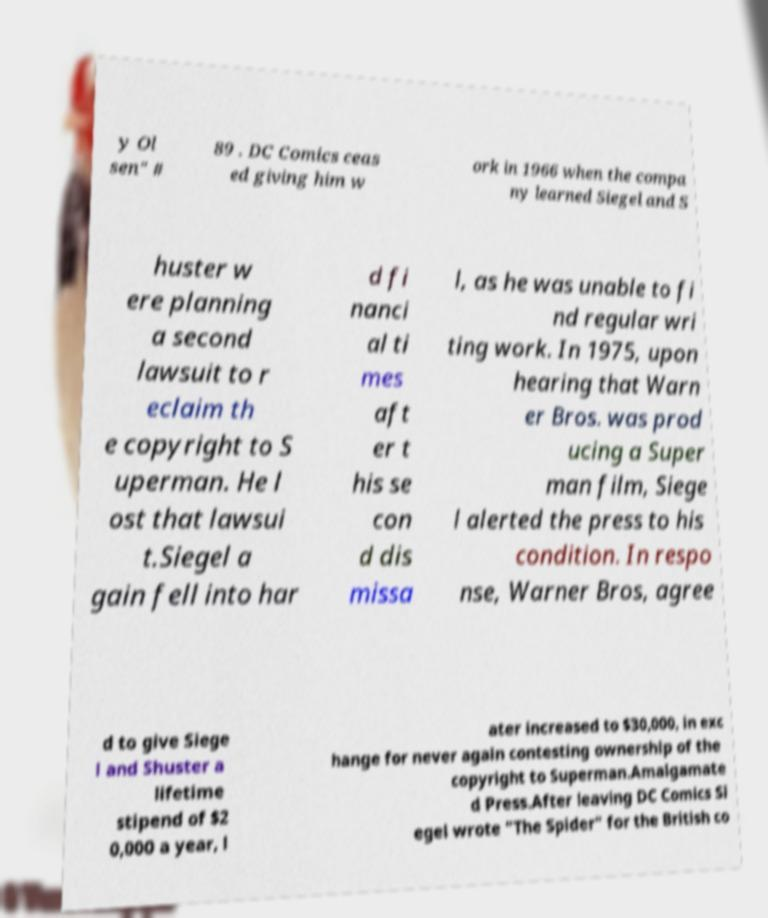Can you read and provide the text displayed in the image?This photo seems to have some interesting text. Can you extract and type it out for me? y Ol sen" # 89 . DC Comics ceas ed giving him w ork in 1966 when the compa ny learned Siegel and S huster w ere planning a second lawsuit to r eclaim th e copyright to S uperman. He l ost that lawsui t.Siegel a gain fell into har d fi nanci al ti mes aft er t his se con d dis missa l, as he was unable to fi nd regular wri ting work. In 1975, upon hearing that Warn er Bros. was prod ucing a Super man film, Siege l alerted the press to his condition. In respo nse, Warner Bros, agree d to give Siege l and Shuster a lifetime stipend of $2 0,000 a year, l ater increased to $30,000, in exc hange for never again contesting ownership of the copyright to Superman.Amalgamate d Press.After leaving DC Comics Si egel wrote "The Spider" for the British co 